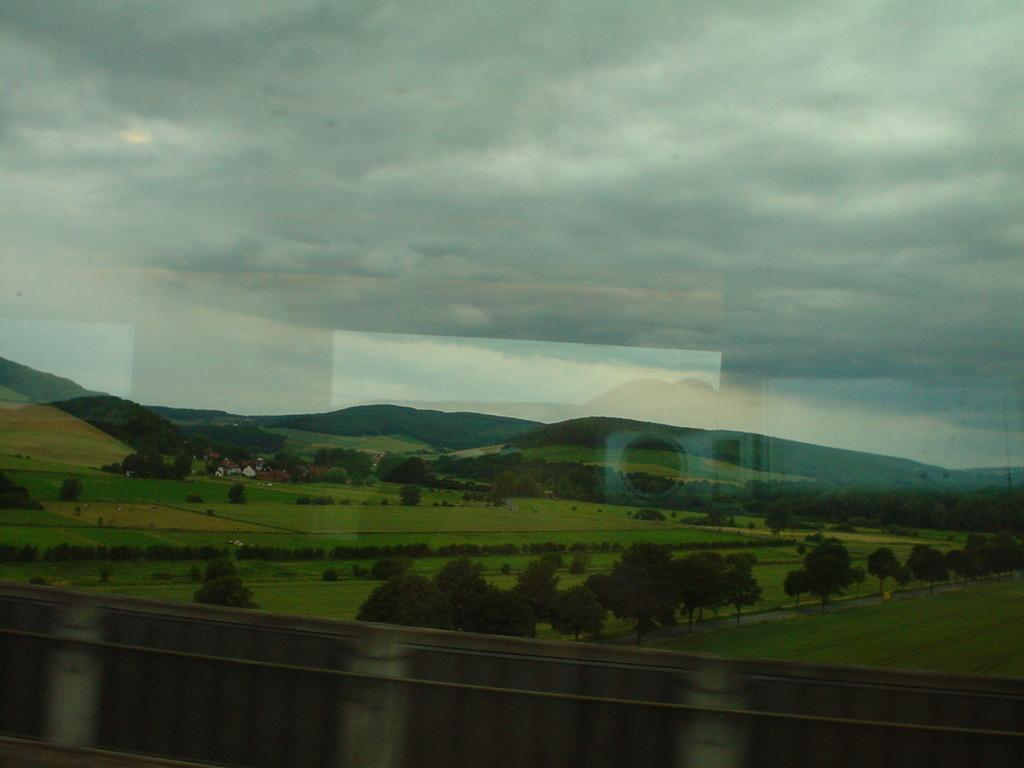What type of natural environment is depicted in the image? The image contains trees, mountains, and fields, which are all part of a natural environment. What can be seen in the background of the image? The sky is visible in the background of the image. What is present in the sky? Clouds are present in the sky. How many children are wearing coats in the image? There are no children present in the image, so it is not possible to determine how many might be wearing coats. 